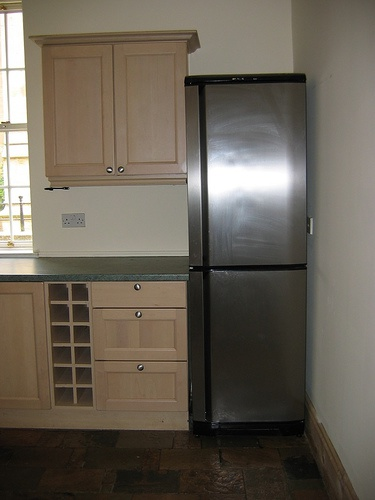Describe the objects in this image and their specific colors. I can see a refrigerator in olive, black, gray, white, and darkgray tones in this image. 